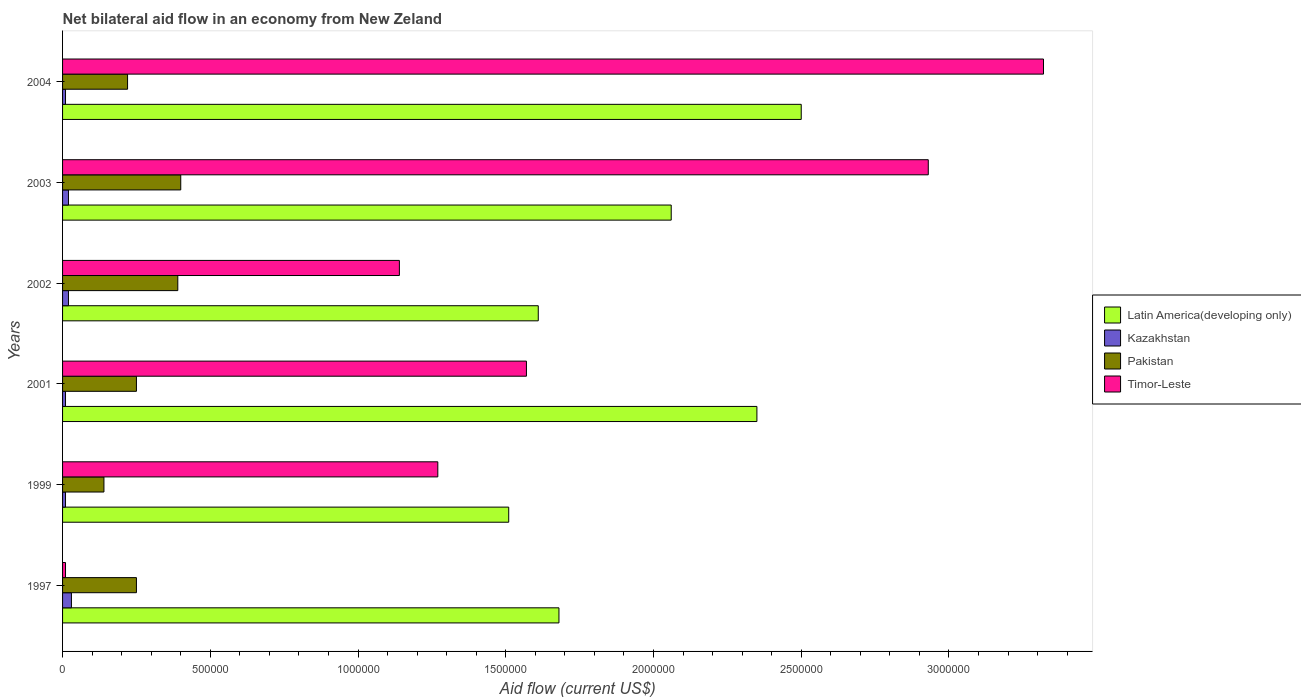Are the number of bars per tick equal to the number of legend labels?
Offer a terse response. Yes. In how many cases, is the number of bars for a given year not equal to the number of legend labels?
Provide a short and direct response. 0. What is the net bilateral aid flow in Timor-Leste in 2002?
Make the answer very short. 1.14e+06. Across all years, what is the maximum net bilateral aid flow in Pakistan?
Make the answer very short. 4.00e+05. Across all years, what is the minimum net bilateral aid flow in Pakistan?
Keep it short and to the point. 1.40e+05. In which year was the net bilateral aid flow in Kazakhstan minimum?
Provide a succinct answer. 1999. What is the difference between the net bilateral aid flow in Kazakhstan in 2002 and that in 2003?
Your answer should be compact. 0. What is the difference between the net bilateral aid flow in Kazakhstan in 2001 and the net bilateral aid flow in Pakistan in 2002?
Keep it short and to the point. -3.80e+05. What is the average net bilateral aid flow in Pakistan per year?
Give a very brief answer. 2.75e+05. In the year 2001, what is the difference between the net bilateral aid flow in Timor-Leste and net bilateral aid flow in Pakistan?
Your answer should be compact. 1.32e+06. What is the ratio of the net bilateral aid flow in Kazakhstan in 2001 to that in 2002?
Keep it short and to the point. 0.5. Is the net bilateral aid flow in Pakistan in 1997 less than that in 1999?
Offer a very short reply. No. Is the difference between the net bilateral aid flow in Timor-Leste in 2002 and 2004 greater than the difference between the net bilateral aid flow in Pakistan in 2002 and 2004?
Offer a very short reply. No. What is the difference between the highest and the lowest net bilateral aid flow in Timor-Leste?
Ensure brevity in your answer.  3.31e+06. What does the 1st bar from the top in 1999 represents?
Provide a succinct answer. Timor-Leste. What does the 1st bar from the bottom in 2003 represents?
Ensure brevity in your answer.  Latin America(developing only). Are all the bars in the graph horizontal?
Your answer should be compact. Yes. Are the values on the major ticks of X-axis written in scientific E-notation?
Offer a terse response. No. Does the graph contain any zero values?
Provide a short and direct response. No. How many legend labels are there?
Make the answer very short. 4. How are the legend labels stacked?
Provide a short and direct response. Vertical. What is the title of the graph?
Offer a terse response. Net bilateral aid flow in an economy from New Zeland. Does "Least developed countries" appear as one of the legend labels in the graph?
Provide a short and direct response. No. What is the label or title of the Y-axis?
Offer a very short reply. Years. What is the Aid flow (current US$) of Latin America(developing only) in 1997?
Provide a succinct answer. 1.68e+06. What is the Aid flow (current US$) in Timor-Leste in 1997?
Give a very brief answer. 10000. What is the Aid flow (current US$) in Latin America(developing only) in 1999?
Your response must be concise. 1.51e+06. What is the Aid flow (current US$) of Timor-Leste in 1999?
Your answer should be very brief. 1.27e+06. What is the Aid flow (current US$) of Latin America(developing only) in 2001?
Offer a terse response. 2.35e+06. What is the Aid flow (current US$) in Timor-Leste in 2001?
Ensure brevity in your answer.  1.57e+06. What is the Aid flow (current US$) of Latin America(developing only) in 2002?
Ensure brevity in your answer.  1.61e+06. What is the Aid flow (current US$) in Pakistan in 2002?
Provide a succinct answer. 3.90e+05. What is the Aid flow (current US$) of Timor-Leste in 2002?
Give a very brief answer. 1.14e+06. What is the Aid flow (current US$) of Latin America(developing only) in 2003?
Your answer should be very brief. 2.06e+06. What is the Aid flow (current US$) of Pakistan in 2003?
Make the answer very short. 4.00e+05. What is the Aid flow (current US$) of Timor-Leste in 2003?
Provide a succinct answer. 2.93e+06. What is the Aid flow (current US$) of Latin America(developing only) in 2004?
Provide a short and direct response. 2.50e+06. What is the Aid flow (current US$) of Kazakhstan in 2004?
Offer a terse response. 10000. What is the Aid flow (current US$) of Pakistan in 2004?
Offer a terse response. 2.20e+05. What is the Aid flow (current US$) of Timor-Leste in 2004?
Keep it short and to the point. 3.32e+06. Across all years, what is the maximum Aid flow (current US$) of Latin America(developing only)?
Give a very brief answer. 2.50e+06. Across all years, what is the maximum Aid flow (current US$) of Kazakhstan?
Provide a short and direct response. 3.00e+04. Across all years, what is the maximum Aid flow (current US$) in Pakistan?
Give a very brief answer. 4.00e+05. Across all years, what is the maximum Aid flow (current US$) of Timor-Leste?
Ensure brevity in your answer.  3.32e+06. Across all years, what is the minimum Aid flow (current US$) of Latin America(developing only)?
Your answer should be compact. 1.51e+06. Across all years, what is the minimum Aid flow (current US$) in Kazakhstan?
Ensure brevity in your answer.  10000. Across all years, what is the minimum Aid flow (current US$) in Timor-Leste?
Provide a short and direct response. 10000. What is the total Aid flow (current US$) of Latin America(developing only) in the graph?
Your answer should be compact. 1.17e+07. What is the total Aid flow (current US$) of Pakistan in the graph?
Ensure brevity in your answer.  1.65e+06. What is the total Aid flow (current US$) in Timor-Leste in the graph?
Provide a succinct answer. 1.02e+07. What is the difference between the Aid flow (current US$) in Kazakhstan in 1997 and that in 1999?
Provide a short and direct response. 2.00e+04. What is the difference between the Aid flow (current US$) in Timor-Leste in 1997 and that in 1999?
Ensure brevity in your answer.  -1.26e+06. What is the difference between the Aid flow (current US$) of Latin America(developing only) in 1997 and that in 2001?
Your answer should be very brief. -6.70e+05. What is the difference between the Aid flow (current US$) of Pakistan in 1997 and that in 2001?
Keep it short and to the point. 0. What is the difference between the Aid flow (current US$) in Timor-Leste in 1997 and that in 2001?
Your answer should be very brief. -1.56e+06. What is the difference between the Aid flow (current US$) in Latin America(developing only) in 1997 and that in 2002?
Give a very brief answer. 7.00e+04. What is the difference between the Aid flow (current US$) in Timor-Leste in 1997 and that in 2002?
Your answer should be very brief. -1.13e+06. What is the difference between the Aid flow (current US$) in Latin America(developing only) in 1997 and that in 2003?
Your answer should be very brief. -3.80e+05. What is the difference between the Aid flow (current US$) of Kazakhstan in 1997 and that in 2003?
Make the answer very short. 10000. What is the difference between the Aid flow (current US$) in Pakistan in 1997 and that in 2003?
Your answer should be compact. -1.50e+05. What is the difference between the Aid flow (current US$) in Timor-Leste in 1997 and that in 2003?
Provide a succinct answer. -2.92e+06. What is the difference between the Aid flow (current US$) of Latin America(developing only) in 1997 and that in 2004?
Your answer should be very brief. -8.20e+05. What is the difference between the Aid flow (current US$) of Kazakhstan in 1997 and that in 2004?
Make the answer very short. 2.00e+04. What is the difference between the Aid flow (current US$) of Timor-Leste in 1997 and that in 2004?
Offer a terse response. -3.31e+06. What is the difference between the Aid flow (current US$) of Latin America(developing only) in 1999 and that in 2001?
Offer a very short reply. -8.40e+05. What is the difference between the Aid flow (current US$) of Kazakhstan in 1999 and that in 2001?
Offer a very short reply. 0. What is the difference between the Aid flow (current US$) in Pakistan in 1999 and that in 2001?
Keep it short and to the point. -1.10e+05. What is the difference between the Aid flow (current US$) in Latin America(developing only) in 1999 and that in 2002?
Provide a short and direct response. -1.00e+05. What is the difference between the Aid flow (current US$) of Kazakhstan in 1999 and that in 2002?
Ensure brevity in your answer.  -10000. What is the difference between the Aid flow (current US$) of Pakistan in 1999 and that in 2002?
Your answer should be compact. -2.50e+05. What is the difference between the Aid flow (current US$) in Timor-Leste in 1999 and that in 2002?
Offer a terse response. 1.30e+05. What is the difference between the Aid flow (current US$) in Latin America(developing only) in 1999 and that in 2003?
Make the answer very short. -5.50e+05. What is the difference between the Aid flow (current US$) of Pakistan in 1999 and that in 2003?
Offer a terse response. -2.60e+05. What is the difference between the Aid flow (current US$) of Timor-Leste in 1999 and that in 2003?
Your answer should be very brief. -1.66e+06. What is the difference between the Aid flow (current US$) in Latin America(developing only) in 1999 and that in 2004?
Make the answer very short. -9.90e+05. What is the difference between the Aid flow (current US$) of Timor-Leste in 1999 and that in 2004?
Ensure brevity in your answer.  -2.05e+06. What is the difference between the Aid flow (current US$) of Latin America(developing only) in 2001 and that in 2002?
Ensure brevity in your answer.  7.40e+05. What is the difference between the Aid flow (current US$) of Kazakhstan in 2001 and that in 2002?
Your answer should be very brief. -10000. What is the difference between the Aid flow (current US$) in Pakistan in 2001 and that in 2002?
Offer a very short reply. -1.40e+05. What is the difference between the Aid flow (current US$) in Timor-Leste in 2001 and that in 2002?
Your answer should be compact. 4.30e+05. What is the difference between the Aid flow (current US$) in Latin America(developing only) in 2001 and that in 2003?
Ensure brevity in your answer.  2.90e+05. What is the difference between the Aid flow (current US$) in Kazakhstan in 2001 and that in 2003?
Your answer should be very brief. -10000. What is the difference between the Aid flow (current US$) of Pakistan in 2001 and that in 2003?
Your response must be concise. -1.50e+05. What is the difference between the Aid flow (current US$) in Timor-Leste in 2001 and that in 2003?
Your answer should be very brief. -1.36e+06. What is the difference between the Aid flow (current US$) of Latin America(developing only) in 2001 and that in 2004?
Provide a short and direct response. -1.50e+05. What is the difference between the Aid flow (current US$) of Timor-Leste in 2001 and that in 2004?
Offer a terse response. -1.75e+06. What is the difference between the Aid flow (current US$) in Latin America(developing only) in 2002 and that in 2003?
Your response must be concise. -4.50e+05. What is the difference between the Aid flow (current US$) in Pakistan in 2002 and that in 2003?
Offer a very short reply. -10000. What is the difference between the Aid flow (current US$) in Timor-Leste in 2002 and that in 2003?
Offer a terse response. -1.79e+06. What is the difference between the Aid flow (current US$) in Latin America(developing only) in 2002 and that in 2004?
Provide a succinct answer. -8.90e+05. What is the difference between the Aid flow (current US$) of Kazakhstan in 2002 and that in 2004?
Give a very brief answer. 10000. What is the difference between the Aid flow (current US$) in Timor-Leste in 2002 and that in 2004?
Offer a very short reply. -2.18e+06. What is the difference between the Aid flow (current US$) in Latin America(developing only) in 2003 and that in 2004?
Make the answer very short. -4.40e+05. What is the difference between the Aid flow (current US$) in Pakistan in 2003 and that in 2004?
Provide a short and direct response. 1.80e+05. What is the difference between the Aid flow (current US$) in Timor-Leste in 2003 and that in 2004?
Provide a succinct answer. -3.90e+05. What is the difference between the Aid flow (current US$) of Latin America(developing only) in 1997 and the Aid flow (current US$) of Kazakhstan in 1999?
Make the answer very short. 1.67e+06. What is the difference between the Aid flow (current US$) in Latin America(developing only) in 1997 and the Aid flow (current US$) in Pakistan in 1999?
Keep it short and to the point. 1.54e+06. What is the difference between the Aid flow (current US$) in Kazakhstan in 1997 and the Aid flow (current US$) in Timor-Leste in 1999?
Give a very brief answer. -1.24e+06. What is the difference between the Aid flow (current US$) of Pakistan in 1997 and the Aid flow (current US$) of Timor-Leste in 1999?
Your response must be concise. -1.02e+06. What is the difference between the Aid flow (current US$) in Latin America(developing only) in 1997 and the Aid flow (current US$) in Kazakhstan in 2001?
Give a very brief answer. 1.67e+06. What is the difference between the Aid flow (current US$) of Latin America(developing only) in 1997 and the Aid flow (current US$) of Pakistan in 2001?
Ensure brevity in your answer.  1.43e+06. What is the difference between the Aid flow (current US$) of Latin America(developing only) in 1997 and the Aid flow (current US$) of Timor-Leste in 2001?
Your answer should be compact. 1.10e+05. What is the difference between the Aid flow (current US$) in Kazakhstan in 1997 and the Aid flow (current US$) in Timor-Leste in 2001?
Provide a succinct answer. -1.54e+06. What is the difference between the Aid flow (current US$) in Pakistan in 1997 and the Aid flow (current US$) in Timor-Leste in 2001?
Your response must be concise. -1.32e+06. What is the difference between the Aid flow (current US$) in Latin America(developing only) in 1997 and the Aid flow (current US$) in Kazakhstan in 2002?
Provide a short and direct response. 1.66e+06. What is the difference between the Aid flow (current US$) in Latin America(developing only) in 1997 and the Aid flow (current US$) in Pakistan in 2002?
Your answer should be very brief. 1.29e+06. What is the difference between the Aid flow (current US$) of Latin America(developing only) in 1997 and the Aid flow (current US$) of Timor-Leste in 2002?
Make the answer very short. 5.40e+05. What is the difference between the Aid flow (current US$) in Kazakhstan in 1997 and the Aid flow (current US$) in Pakistan in 2002?
Provide a succinct answer. -3.60e+05. What is the difference between the Aid flow (current US$) of Kazakhstan in 1997 and the Aid flow (current US$) of Timor-Leste in 2002?
Offer a very short reply. -1.11e+06. What is the difference between the Aid flow (current US$) of Pakistan in 1997 and the Aid flow (current US$) of Timor-Leste in 2002?
Offer a very short reply. -8.90e+05. What is the difference between the Aid flow (current US$) of Latin America(developing only) in 1997 and the Aid flow (current US$) of Kazakhstan in 2003?
Give a very brief answer. 1.66e+06. What is the difference between the Aid flow (current US$) in Latin America(developing only) in 1997 and the Aid flow (current US$) in Pakistan in 2003?
Provide a succinct answer. 1.28e+06. What is the difference between the Aid flow (current US$) of Latin America(developing only) in 1997 and the Aid flow (current US$) of Timor-Leste in 2003?
Give a very brief answer. -1.25e+06. What is the difference between the Aid flow (current US$) in Kazakhstan in 1997 and the Aid flow (current US$) in Pakistan in 2003?
Your answer should be very brief. -3.70e+05. What is the difference between the Aid flow (current US$) of Kazakhstan in 1997 and the Aid flow (current US$) of Timor-Leste in 2003?
Provide a succinct answer. -2.90e+06. What is the difference between the Aid flow (current US$) of Pakistan in 1997 and the Aid flow (current US$) of Timor-Leste in 2003?
Offer a terse response. -2.68e+06. What is the difference between the Aid flow (current US$) in Latin America(developing only) in 1997 and the Aid flow (current US$) in Kazakhstan in 2004?
Your answer should be very brief. 1.67e+06. What is the difference between the Aid flow (current US$) in Latin America(developing only) in 1997 and the Aid flow (current US$) in Pakistan in 2004?
Offer a very short reply. 1.46e+06. What is the difference between the Aid flow (current US$) in Latin America(developing only) in 1997 and the Aid flow (current US$) in Timor-Leste in 2004?
Your response must be concise. -1.64e+06. What is the difference between the Aid flow (current US$) in Kazakhstan in 1997 and the Aid flow (current US$) in Pakistan in 2004?
Ensure brevity in your answer.  -1.90e+05. What is the difference between the Aid flow (current US$) of Kazakhstan in 1997 and the Aid flow (current US$) of Timor-Leste in 2004?
Offer a terse response. -3.29e+06. What is the difference between the Aid flow (current US$) of Pakistan in 1997 and the Aid flow (current US$) of Timor-Leste in 2004?
Provide a short and direct response. -3.07e+06. What is the difference between the Aid flow (current US$) of Latin America(developing only) in 1999 and the Aid flow (current US$) of Kazakhstan in 2001?
Give a very brief answer. 1.50e+06. What is the difference between the Aid flow (current US$) of Latin America(developing only) in 1999 and the Aid flow (current US$) of Pakistan in 2001?
Give a very brief answer. 1.26e+06. What is the difference between the Aid flow (current US$) of Latin America(developing only) in 1999 and the Aid flow (current US$) of Timor-Leste in 2001?
Your response must be concise. -6.00e+04. What is the difference between the Aid flow (current US$) of Kazakhstan in 1999 and the Aid flow (current US$) of Timor-Leste in 2001?
Give a very brief answer. -1.56e+06. What is the difference between the Aid flow (current US$) of Pakistan in 1999 and the Aid flow (current US$) of Timor-Leste in 2001?
Your answer should be very brief. -1.43e+06. What is the difference between the Aid flow (current US$) of Latin America(developing only) in 1999 and the Aid flow (current US$) of Kazakhstan in 2002?
Your response must be concise. 1.49e+06. What is the difference between the Aid flow (current US$) in Latin America(developing only) in 1999 and the Aid flow (current US$) in Pakistan in 2002?
Your answer should be compact. 1.12e+06. What is the difference between the Aid flow (current US$) of Latin America(developing only) in 1999 and the Aid flow (current US$) of Timor-Leste in 2002?
Ensure brevity in your answer.  3.70e+05. What is the difference between the Aid flow (current US$) in Kazakhstan in 1999 and the Aid flow (current US$) in Pakistan in 2002?
Provide a short and direct response. -3.80e+05. What is the difference between the Aid flow (current US$) of Kazakhstan in 1999 and the Aid flow (current US$) of Timor-Leste in 2002?
Your response must be concise. -1.13e+06. What is the difference between the Aid flow (current US$) of Latin America(developing only) in 1999 and the Aid flow (current US$) of Kazakhstan in 2003?
Offer a very short reply. 1.49e+06. What is the difference between the Aid flow (current US$) in Latin America(developing only) in 1999 and the Aid flow (current US$) in Pakistan in 2003?
Provide a succinct answer. 1.11e+06. What is the difference between the Aid flow (current US$) in Latin America(developing only) in 1999 and the Aid flow (current US$) in Timor-Leste in 2003?
Provide a succinct answer. -1.42e+06. What is the difference between the Aid flow (current US$) in Kazakhstan in 1999 and the Aid flow (current US$) in Pakistan in 2003?
Your answer should be very brief. -3.90e+05. What is the difference between the Aid flow (current US$) in Kazakhstan in 1999 and the Aid flow (current US$) in Timor-Leste in 2003?
Your answer should be very brief. -2.92e+06. What is the difference between the Aid flow (current US$) in Pakistan in 1999 and the Aid flow (current US$) in Timor-Leste in 2003?
Ensure brevity in your answer.  -2.79e+06. What is the difference between the Aid flow (current US$) in Latin America(developing only) in 1999 and the Aid flow (current US$) in Kazakhstan in 2004?
Provide a short and direct response. 1.50e+06. What is the difference between the Aid flow (current US$) in Latin America(developing only) in 1999 and the Aid flow (current US$) in Pakistan in 2004?
Provide a short and direct response. 1.29e+06. What is the difference between the Aid flow (current US$) in Latin America(developing only) in 1999 and the Aid flow (current US$) in Timor-Leste in 2004?
Your answer should be very brief. -1.81e+06. What is the difference between the Aid flow (current US$) of Kazakhstan in 1999 and the Aid flow (current US$) of Pakistan in 2004?
Provide a short and direct response. -2.10e+05. What is the difference between the Aid flow (current US$) in Kazakhstan in 1999 and the Aid flow (current US$) in Timor-Leste in 2004?
Your response must be concise. -3.31e+06. What is the difference between the Aid flow (current US$) of Pakistan in 1999 and the Aid flow (current US$) of Timor-Leste in 2004?
Your answer should be compact. -3.18e+06. What is the difference between the Aid flow (current US$) of Latin America(developing only) in 2001 and the Aid flow (current US$) of Kazakhstan in 2002?
Keep it short and to the point. 2.33e+06. What is the difference between the Aid flow (current US$) in Latin America(developing only) in 2001 and the Aid flow (current US$) in Pakistan in 2002?
Keep it short and to the point. 1.96e+06. What is the difference between the Aid flow (current US$) in Latin America(developing only) in 2001 and the Aid flow (current US$) in Timor-Leste in 2002?
Ensure brevity in your answer.  1.21e+06. What is the difference between the Aid flow (current US$) of Kazakhstan in 2001 and the Aid flow (current US$) of Pakistan in 2002?
Offer a very short reply. -3.80e+05. What is the difference between the Aid flow (current US$) in Kazakhstan in 2001 and the Aid flow (current US$) in Timor-Leste in 2002?
Your answer should be very brief. -1.13e+06. What is the difference between the Aid flow (current US$) of Pakistan in 2001 and the Aid flow (current US$) of Timor-Leste in 2002?
Give a very brief answer. -8.90e+05. What is the difference between the Aid flow (current US$) of Latin America(developing only) in 2001 and the Aid flow (current US$) of Kazakhstan in 2003?
Your answer should be very brief. 2.33e+06. What is the difference between the Aid flow (current US$) of Latin America(developing only) in 2001 and the Aid flow (current US$) of Pakistan in 2003?
Your response must be concise. 1.95e+06. What is the difference between the Aid flow (current US$) in Latin America(developing only) in 2001 and the Aid flow (current US$) in Timor-Leste in 2003?
Make the answer very short. -5.80e+05. What is the difference between the Aid flow (current US$) in Kazakhstan in 2001 and the Aid flow (current US$) in Pakistan in 2003?
Provide a short and direct response. -3.90e+05. What is the difference between the Aid flow (current US$) of Kazakhstan in 2001 and the Aid flow (current US$) of Timor-Leste in 2003?
Your response must be concise. -2.92e+06. What is the difference between the Aid flow (current US$) in Pakistan in 2001 and the Aid flow (current US$) in Timor-Leste in 2003?
Ensure brevity in your answer.  -2.68e+06. What is the difference between the Aid flow (current US$) of Latin America(developing only) in 2001 and the Aid flow (current US$) of Kazakhstan in 2004?
Make the answer very short. 2.34e+06. What is the difference between the Aid flow (current US$) in Latin America(developing only) in 2001 and the Aid flow (current US$) in Pakistan in 2004?
Give a very brief answer. 2.13e+06. What is the difference between the Aid flow (current US$) of Latin America(developing only) in 2001 and the Aid flow (current US$) of Timor-Leste in 2004?
Keep it short and to the point. -9.70e+05. What is the difference between the Aid flow (current US$) of Kazakhstan in 2001 and the Aid flow (current US$) of Timor-Leste in 2004?
Make the answer very short. -3.31e+06. What is the difference between the Aid flow (current US$) of Pakistan in 2001 and the Aid flow (current US$) of Timor-Leste in 2004?
Your answer should be very brief. -3.07e+06. What is the difference between the Aid flow (current US$) of Latin America(developing only) in 2002 and the Aid flow (current US$) of Kazakhstan in 2003?
Provide a succinct answer. 1.59e+06. What is the difference between the Aid flow (current US$) of Latin America(developing only) in 2002 and the Aid flow (current US$) of Pakistan in 2003?
Ensure brevity in your answer.  1.21e+06. What is the difference between the Aid flow (current US$) of Latin America(developing only) in 2002 and the Aid flow (current US$) of Timor-Leste in 2003?
Your response must be concise. -1.32e+06. What is the difference between the Aid flow (current US$) in Kazakhstan in 2002 and the Aid flow (current US$) in Pakistan in 2003?
Provide a short and direct response. -3.80e+05. What is the difference between the Aid flow (current US$) of Kazakhstan in 2002 and the Aid flow (current US$) of Timor-Leste in 2003?
Offer a very short reply. -2.91e+06. What is the difference between the Aid flow (current US$) of Pakistan in 2002 and the Aid flow (current US$) of Timor-Leste in 2003?
Provide a short and direct response. -2.54e+06. What is the difference between the Aid flow (current US$) of Latin America(developing only) in 2002 and the Aid flow (current US$) of Kazakhstan in 2004?
Offer a very short reply. 1.60e+06. What is the difference between the Aid flow (current US$) of Latin America(developing only) in 2002 and the Aid flow (current US$) of Pakistan in 2004?
Ensure brevity in your answer.  1.39e+06. What is the difference between the Aid flow (current US$) in Latin America(developing only) in 2002 and the Aid flow (current US$) in Timor-Leste in 2004?
Keep it short and to the point. -1.71e+06. What is the difference between the Aid flow (current US$) in Kazakhstan in 2002 and the Aid flow (current US$) in Pakistan in 2004?
Your answer should be compact. -2.00e+05. What is the difference between the Aid flow (current US$) of Kazakhstan in 2002 and the Aid flow (current US$) of Timor-Leste in 2004?
Give a very brief answer. -3.30e+06. What is the difference between the Aid flow (current US$) in Pakistan in 2002 and the Aid flow (current US$) in Timor-Leste in 2004?
Your answer should be compact. -2.93e+06. What is the difference between the Aid flow (current US$) in Latin America(developing only) in 2003 and the Aid flow (current US$) in Kazakhstan in 2004?
Offer a very short reply. 2.05e+06. What is the difference between the Aid flow (current US$) in Latin America(developing only) in 2003 and the Aid flow (current US$) in Pakistan in 2004?
Offer a terse response. 1.84e+06. What is the difference between the Aid flow (current US$) in Latin America(developing only) in 2003 and the Aid flow (current US$) in Timor-Leste in 2004?
Provide a short and direct response. -1.26e+06. What is the difference between the Aid flow (current US$) in Kazakhstan in 2003 and the Aid flow (current US$) in Timor-Leste in 2004?
Your answer should be compact. -3.30e+06. What is the difference between the Aid flow (current US$) of Pakistan in 2003 and the Aid flow (current US$) of Timor-Leste in 2004?
Your answer should be very brief. -2.92e+06. What is the average Aid flow (current US$) of Latin America(developing only) per year?
Your answer should be very brief. 1.95e+06. What is the average Aid flow (current US$) in Kazakhstan per year?
Your response must be concise. 1.67e+04. What is the average Aid flow (current US$) in Pakistan per year?
Ensure brevity in your answer.  2.75e+05. What is the average Aid flow (current US$) in Timor-Leste per year?
Your answer should be compact. 1.71e+06. In the year 1997, what is the difference between the Aid flow (current US$) in Latin America(developing only) and Aid flow (current US$) in Kazakhstan?
Your answer should be very brief. 1.65e+06. In the year 1997, what is the difference between the Aid flow (current US$) in Latin America(developing only) and Aid flow (current US$) in Pakistan?
Ensure brevity in your answer.  1.43e+06. In the year 1997, what is the difference between the Aid flow (current US$) in Latin America(developing only) and Aid flow (current US$) in Timor-Leste?
Provide a short and direct response. 1.67e+06. In the year 1997, what is the difference between the Aid flow (current US$) in Kazakhstan and Aid flow (current US$) in Pakistan?
Offer a very short reply. -2.20e+05. In the year 1999, what is the difference between the Aid flow (current US$) in Latin America(developing only) and Aid flow (current US$) in Kazakhstan?
Provide a succinct answer. 1.50e+06. In the year 1999, what is the difference between the Aid flow (current US$) of Latin America(developing only) and Aid flow (current US$) of Pakistan?
Your answer should be compact. 1.37e+06. In the year 1999, what is the difference between the Aid flow (current US$) in Kazakhstan and Aid flow (current US$) in Pakistan?
Keep it short and to the point. -1.30e+05. In the year 1999, what is the difference between the Aid flow (current US$) of Kazakhstan and Aid flow (current US$) of Timor-Leste?
Give a very brief answer. -1.26e+06. In the year 1999, what is the difference between the Aid flow (current US$) in Pakistan and Aid flow (current US$) in Timor-Leste?
Give a very brief answer. -1.13e+06. In the year 2001, what is the difference between the Aid flow (current US$) of Latin America(developing only) and Aid flow (current US$) of Kazakhstan?
Provide a succinct answer. 2.34e+06. In the year 2001, what is the difference between the Aid flow (current US$) in Latin America(developing only) and Aid flow (current US$) in Pakistan?
Make the answer very short. 2.10e+06. In the year 2001, what is the difference between the Aid flow (current US$) of Latin America(developing only) and Aid flow (current US$) of Timor-Leste?
Ensure brevity in your answer.  7.80e+05. In the year 2001, what is the difference between the Aid flow (current US$) in Kazakhstan and Aid flow (current US$) in Timor-Leste?
Your response must be concise. -1.56e+06. In the year 2001, what is the difference between the Aid flow (current US$) of Pakistan and Aid flow (current US$) of Timor-Leste?
Make the answer very short. -1.32e+06. In the year 2002, what is the difference between the Aid flow (current US$) of Latin America(developing only) and Aid flow (current US$) of Kazakhstan?
Ensure brevity in your answer.  1.59e+06. In the year 2002, what is the difference between the Aid flow (current US$) of Latin America(developing only) and Aid flow (current US$) of Pakistan?
Your response must be concise. 1.22e+06. In the year 2002, what is the difference between the Aid flow (current US$) of Latin America(developing only) and Aid flow (current US$) of Timor-Leste?
Keep it short and to the point. 4.70e+05. In the year 2002, what is the difference between the Aid flow (current US$) of Kazakhstan and Aid flow (current US$) of Pakistan?
Ensure brevity in your answer.  -3.70e+05. In the year 2002, what is the difference between the Aid flow (current US$) of Kazakhstan and Aid flow (current US$) of Timor-Leste?
Ensure brevity in your answer.  -1.12e+06. In the year 2002, what is the difference between the Aid flow (current US$) of Pakistan and Aid flow (current US$) of Timor-Leste?
Offer a very short reply. -7.50e+05. In the year 2003, what is the difference between the Aid flow (current US$) of Latin America(developing only) and Aid flow (current US$) of Kazakhstan?
Keep it short and to the point. 2.04e+06. In the year 2003, what is the difference between the Aid flow (current US$) of Latin America(developing only) and Aid flow (current US$) of Pakistan?
Ensure brevity in your answer.  1.66e+06. In the year 2003, what is the difference between the Aid flow (current US$) of Latin America(developing only) and Aid flow (current US$) of Timor-Leste?
Give a very brief answer. -8.70e+05. In the year 2003, what is the difference between the Aid flow (current US$) in Kazakhstan and Aid flow (current US$) in Pakistan?
Give a very brief answer. -3.80e+05. In the year 2003, what is the difference between the Aid flow (current US$) in Kazakhstan and Aid flow (current US$) in Timor-Leste?
Provide a succinct answer. -2.91e+06. In the year 2003, what is the difference between the Aid flow (current US$) of Pakistan and Aid flow (current US$) of Timor-Leste?
Your answer should be very brief. -2.53e+06. In the year 2004, what is the difference between the Aid flow (current US$) in Latin America(developing only) and Aid flow (current US$) in Kazakhstan?
Ensure brevity in your answer.  2.49e+06. In the year 2004, what is the difference between the Aid flow (current US$) of Latin America(developing only) and Aid flow (current US$) of Pakistan?
Make the answer very short. 2.28e+06. In the year 2004, what is the difference between the Aid flow (current US$) in Latin America(developing only) and Aid flow (current US$) in Timor-Leste?
Offer a terse response. -8.20e+05. In the year 2004, what is the difference between the Aid flow (current US$) of Kazakhstan and Aid flow (current US$) of Pakistan?
Your answer should be very brief. -2.10e+05. In the year 2004, what is the difference between the Aid flow (current US$) in Kazakhstan and Aid flow (current US$) in Timor-Leste?
Your answer should be compact. -3.31e+06. In the year 2004, what is the difference between the Aid flow (current US$) in Pakistan and Aid flow (current US$) in Timor-Leste?
Ensure brevity in your answer.  -3.10e+06. What is the ratio of the Aid flow (current US$) in Latin America(developing only) in 1997 to that in 1999?
Keep it short and to the point. 1.11. What is the ratio of the Aid flow (current US$) in Pakistan in 1997 to that in 1999?
Provide a succinct answer. 1.79. What is the ratio of the Aid flow (current US$) of Timor-Leste in 1997 to that in 1999?
Give a very brief answer. 0.01. What is the ratio of the Aid flow (current US$) of Latin America(developing only) in 1997 to that in 2001?
Your answer should be compact. 0.71. What is the ratio of the Aid flow (current US$) in Pakistan in 1997 to that in 2001?
Provide a short and direct response. 1. What is the ratio of the Aid flow (current US$) in Timor-Leste in 1997 to that in 2001?
Provide a short and direct response. 0.01. What is the ratio of the Aid flow (current US$) of Latin America(developing only) in 1997 to that in 2002?
Make the answer very short. 1.04. What is the ratio of the Aid flow (current US$) in Pakistan in 1997 to that in 2002?
Provide a succinct answer. 0.64. What is the ratio of the Aid flow (current US$) of Timor-Leste in 1997 to that in 2002?
Ensure brevity in your answer.  0.01. What is the ratio of the Aid flow (current US$) of Latin America(developing only) in 1997 to that in 2003?
Ensure brevity in your answer.  0.82. What is the ratio of the Aid flow (current US$) in Kazakhstan in 1997 to that in 2003?
Your response must be concise. 1.5. What is the ratio of the Aid flow (current US$) in Pakistan in 1997 to that in 2003?
Ensure brevity in your answer.  0.62. What is the ratio of the Aid flow (current US$) in Timor-Leste in 1997 to that in 2003?
Keep it short and to the point. 0. What is the ratio of the Aid flow (current US$) of Latin America(developing only) in 1997 to that in 2004?
Ensure brevity in your answer.  0.67. What is the ratio of the Aid flow (current US$) of Kazakhstan in 1997 to that in 2004?
Offer a terse response. 3. What is the ratio of the Aid flow (current US$) of Pakistan in 1997 to that in 2004?
Give a very brief answer. 1.14. What is the ratio of the Aid flow (current US$) of Timor-Leste in 1997 to that in 2004?
Offer a terse response. 0. What is the ratio of the Aid flow (current US$) of Latin America(developing only) in 1999 to that in 2001?
Offer a very short reply. 0.64. What is the ratio of the Aid flow (current US$) in Pakistan in 1999 to that in 2001?
Ensure brevity in your answer.  0.56. What is the ratio of the Aid flow (current US$) in Timor-Leste in 1999 to that in 2001?
Provide a succinct answer. 0.81. What is the ratio of the Aid flow (current US$) of Latin America(developing only) in 1999 to that in 2002?
Your answer should be very brief. 0.94. What is the ratio of the Aid flow (current US$) of Pakistan in 1999 to that in 2002?
Keep it short and to the point. 0.36. What is the ratio of the Aid flow (current US$) in Timor-Leste in 1999 to that in 2002?
Provide a succinct answer. 1.11. What is the ratio of the Aid flow (current US$) in Latin America(developing only) in 1999 to that in 2003?
Your answer should be compact. 0.73. What is the ratio of the Aid flow (current US$) in Kazakhstan in 1999 to that in 2003?
Provide a short and direct response. 0.5. What is the ratio of the Aid flow (current US$) of Timor-Leste in 1999 to that in 2003?
Your answer should be compact. 0.43. What is the ratio of the Aid flow (current US$) of Latin America(developing only) in 1999 to that in 2004?
Make the answer very short. 0.6. What is the ratio of the Aid flow (current US$) of Pakistan in 1999 to that in 2004?
Your answer should be compact. 0.64. What is the ratio of the Aid flow (current US$) of Timor-Leste in 1999 to that in 2004?
Offer a terse response. 0.38. What is the ratio of the Aid flow (current US$) of Latin America(developing only) in 2001 to that in 2002?
Provide a short and direct response. 1.46. What is the ratio of the Aid flow (current US$) of Kazakhstan in 2001 to that in 2002?
Make the answer very short. 0.5. What is the ratio of the Aid flow (current US$) of Pakistan in 2001 to that in 2002?
Offer a very short reply. 0.64. What is the ratio of the Aid flow (current US$) of Timor-Leste in 2001 to that in 2002?
Offer a terse response. 1.38. What is the ratio of the Aid flow (current US$) of Latin America(developing only) in 2001 to that in 2003?
Provide a succinct answer. 1.14. What is the ratio of the Aid flow (current US$) in Kazakhstan in 2001 to that in 2003?
Make the answer very short. 0.5. What is the ratio of the Aid flow (current US$) of Pakistan in 2001 to that in 2003?
Keep it short and to the point. 0.62. What is the ratio of the Aid flow (current US$) of Timor-Leste in 2001 to that in 2003?
Offer a very short reply. 0.54. What is the ratio of the Aid flow (current US$) in Latin America(developing only) in 2001 to that in 2004?
Provide a succinct answer. 0.94. What is the ratio of the Aid flow (current US$) in Pakistan in 2001 to that in 2004?
Provide a short and direct response. 1.14. What is the ratio of the Aid flow (current US$) of Timor-Leste in 2001 to that in 2004?
Ensure brevity in your answer.  0.47. What is the ratio of the Aid flow (current US$) in Latin America(developing only) in 2002 to that in 2003?
Provide a short and direct response. 0.78. What is the ratio of the Aid flow (current US$) of Timor-Leste in 2002 to that in 2003?
Your answer should be very brief. 0.39. What is the ratio of the Aid flow (current US$) of Latin America(developing only) in 2002 to that in 2004?
Your response must be concise. 0.64. What is the ratio of the Aid flow (current US$) of Kazakhstan in 2002 to that in 2004?
Your response must be concise. 2. What is the ratio of the Aid flow (current US$) of Pakistan in 2002 to that in 2004?
Ensure brevity in your answer.  1.77. What is the ratio of the Aid flow (current US$) in Timor-Leste in 2002 to that in 2004?
Ensure brevity in your answer.  0.34. What is the ratio of the Aid flow (current US$) in Latin America(developing only) in 2003 to that in 2004?
Your response must be concise. 0.82. What is the ratio of the Aid flow (current US$) in Pakistan in 2003 to that in 2004?
Give a very brief answer. 1.82. What is the ratio of the Aid flow (current US$) in Timor-Leste in 2003 to that in 2004?
Offer a terse response. 0.88. What is the difference between the highest and the second highest Aid flow (current US$) in Kazakhstan?
Provide a succinct answer. 10000. What is the difference between the highest and the second highest Aid flow (current US$) of Timor-Leste?
Provide a short and direct response. 3.90e+05. What is the difference between the highest and the lowest Aid flow (current US$) in Latin America(developing only)?
Make the answer very short. 9.90e+05. What is the difference between the highest and the lowest Aid flow (current US$) of Kazakhstan?
Make the answer very short. 2.00e+04. What is the difference between the highest and the lowest Aid flow (current US$) in Timor-Leste?
Provide a short and direct response. 3.31e+06. 